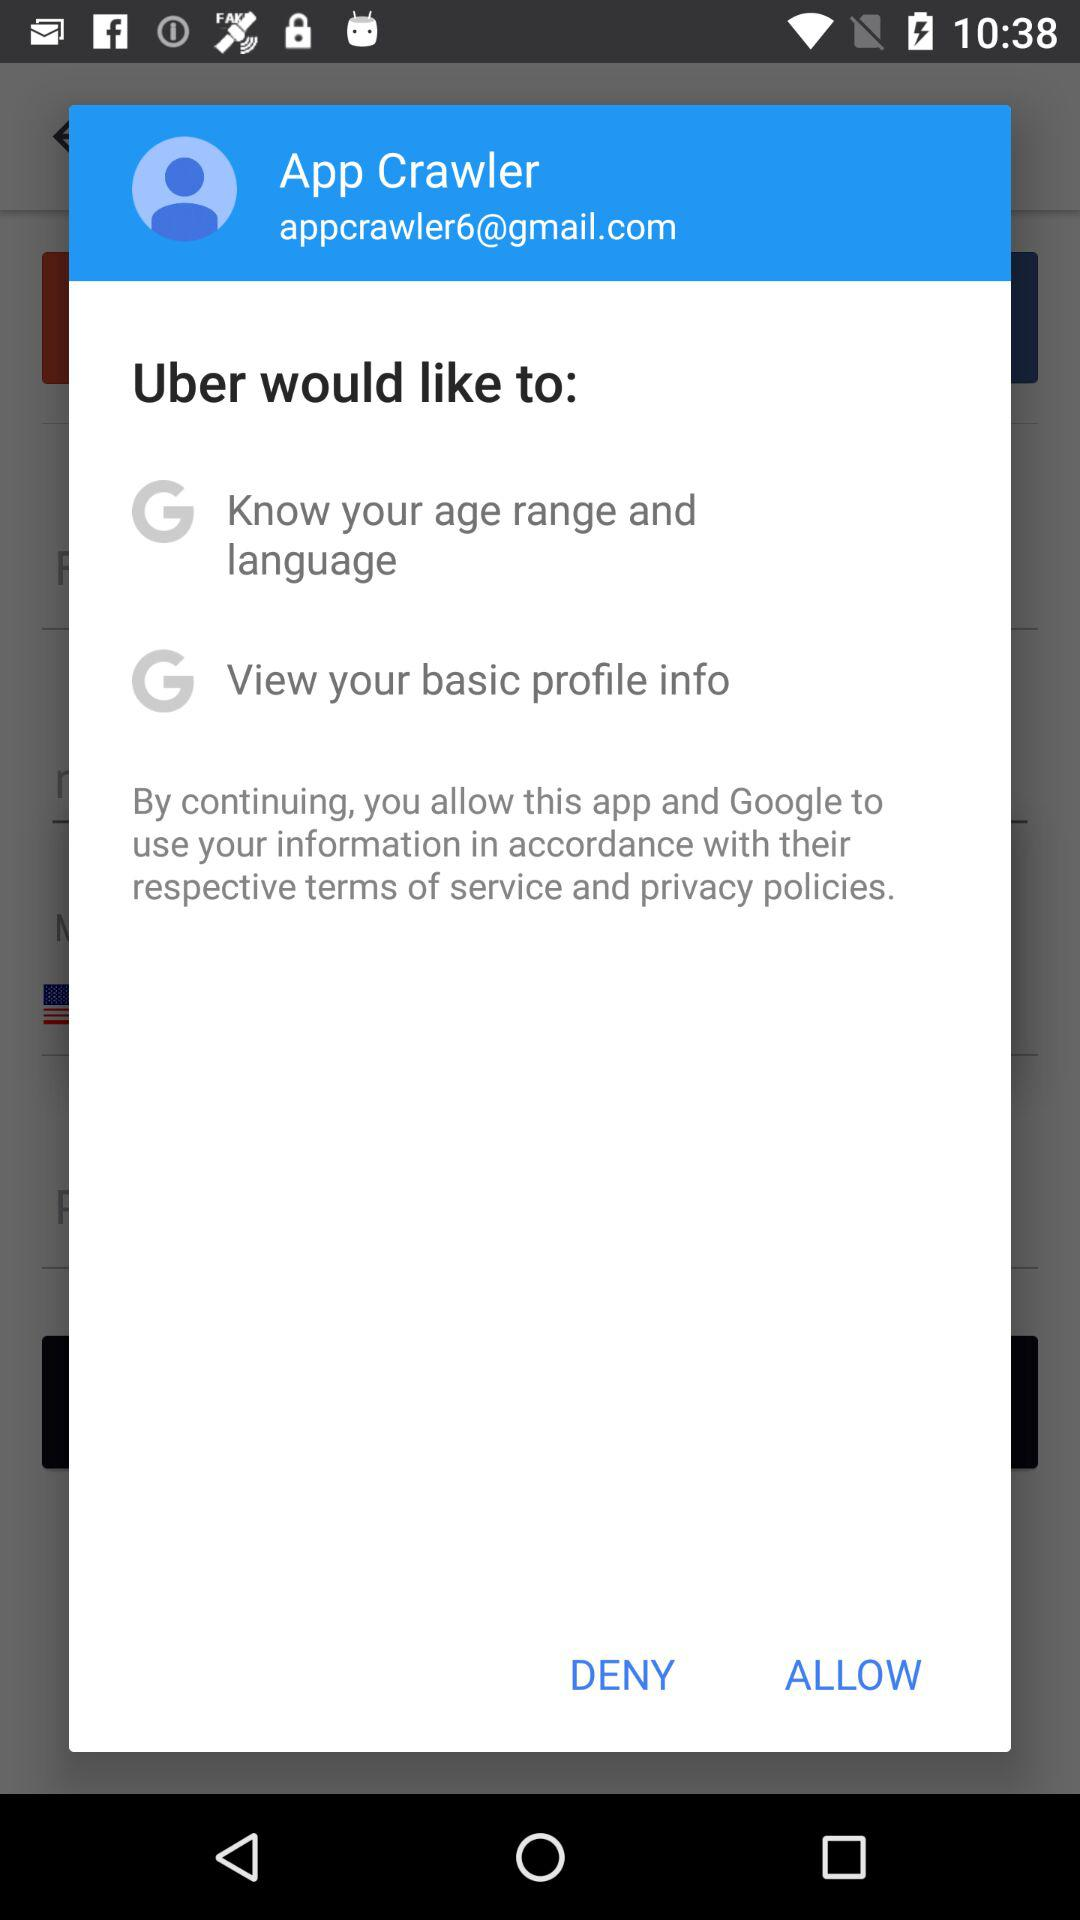What is the name of the user? The user name is App Crawler. 